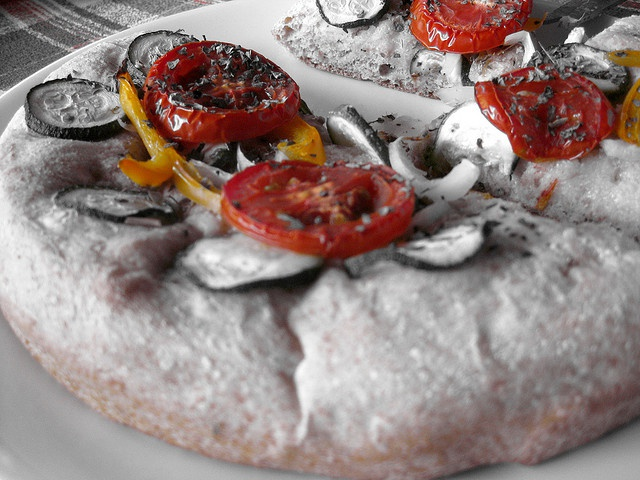Describe the objects in this image and their specific colors. I can see a pizza in black, darkgray, gray, lightgray, and maroon tones in this image. 